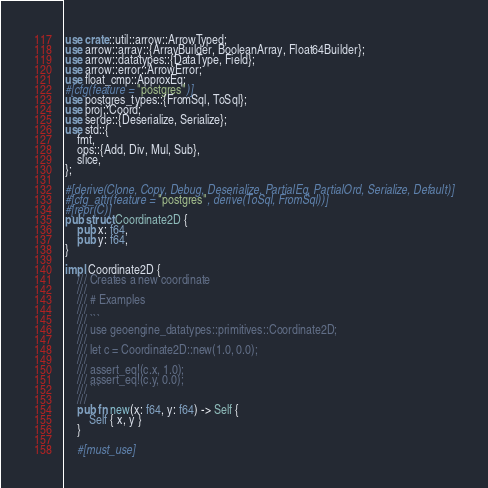Convert code to text. <code><loc_0><loc_0><loc_500><loc_500><_Rust_>use crate::util::arrow::ArrowTyped;
use arrow::array::{ArrayBuilder, BooleanArray, Float64Builder};
use arrow::datatypes::{DataType, Field};
use arrow::error::ArrowError;
use float_cmp::ApproxEq;
#[cfg(feature = "postgres")]
use postgres_types::{FromSql, ToSql};
use proj::Coord;
use serde::{Deserialize, Serialize};
use std::{
    fmt,
    ops::{Add, Div, Mul, Sub},
    slice,
};

#[derive(Clone, Copy, Debug, Deserialize, PartialEq, PartialOrd, Serialize, Default)]
#[cfg_attr(feature = "postgres", derive(ToSql, FromSql))]
#[repr(C)]
pub struct Coordinate2D {
    pub x: f64,
    pub y: f64,
}

impl Coordinate2D {
    /// Creates a new coordinate
    ///
    /// # Examples
    ///
    /// ```
    /// use geoengine_datatypes::primitives::Coordinate2D;
    ///
    /// let c = Coordinate2D::new(1.0, 0.0);
    ///
    /// assert_eq!(c.x, 1.0);
    /// assert_eq!(c.y, 0.0);
    /// ```
    ///
    pub fn new(x: f64, y: f64) -> Self {
        Self { x, y }
    }

    #[must_use]</code> 